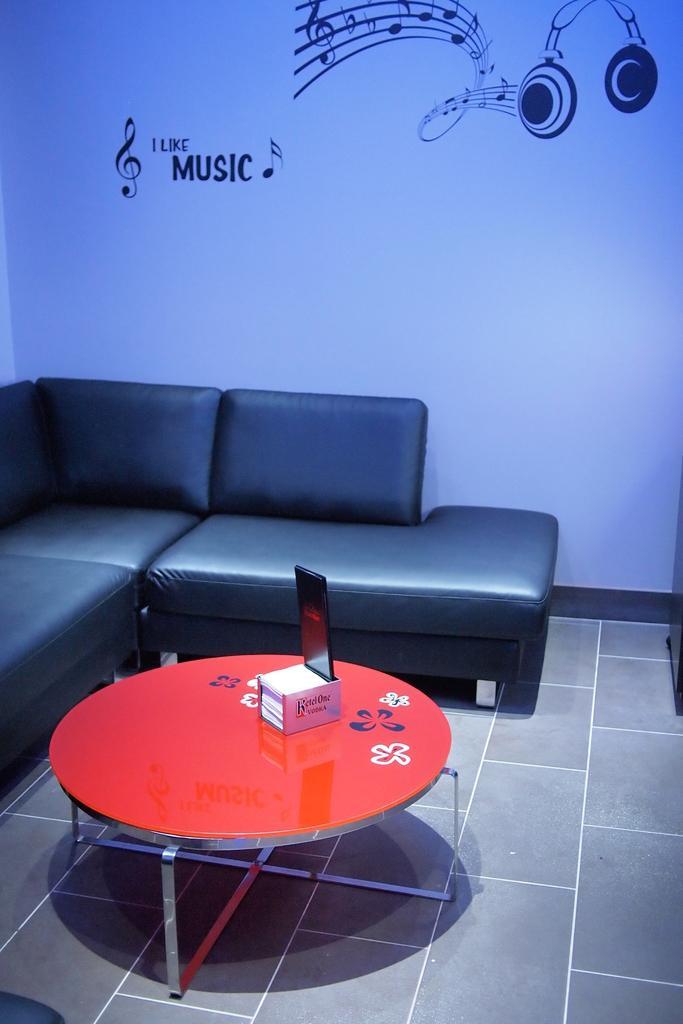Please provide a concise description of this image. In this picture we can see a room with sofa, table and on table there is iPad and for all we have paintings of musical headsets. 